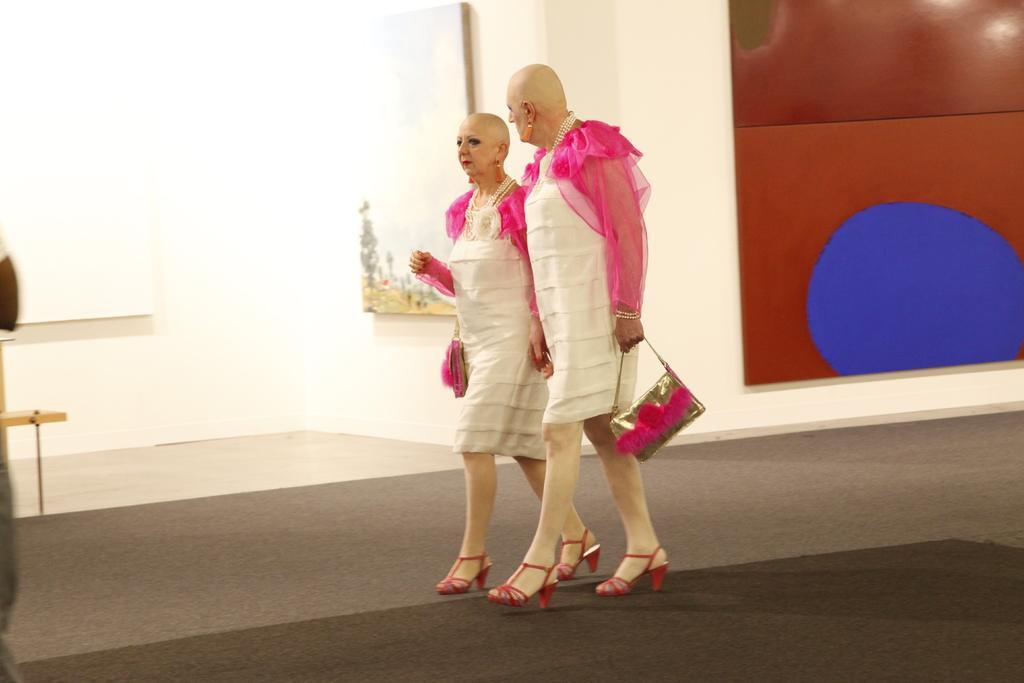Please provide a concise description of this image. This picture describe the two woman wearing pink and white dress with pink color sandals walking in the hall, Holding pink and golden color purse. Behind we can see colorful wallpaper on the wall and a painting. 